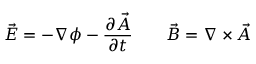<formula> <loc_0><loc_0><loc_500><loc_500>{ \vec { E } } = - \nabla \phi - { \frac { \partial { \vec { A } } } { \partial t } } \quad { \vec { B } } = \nabla \times { \vec { A } }</formula> 